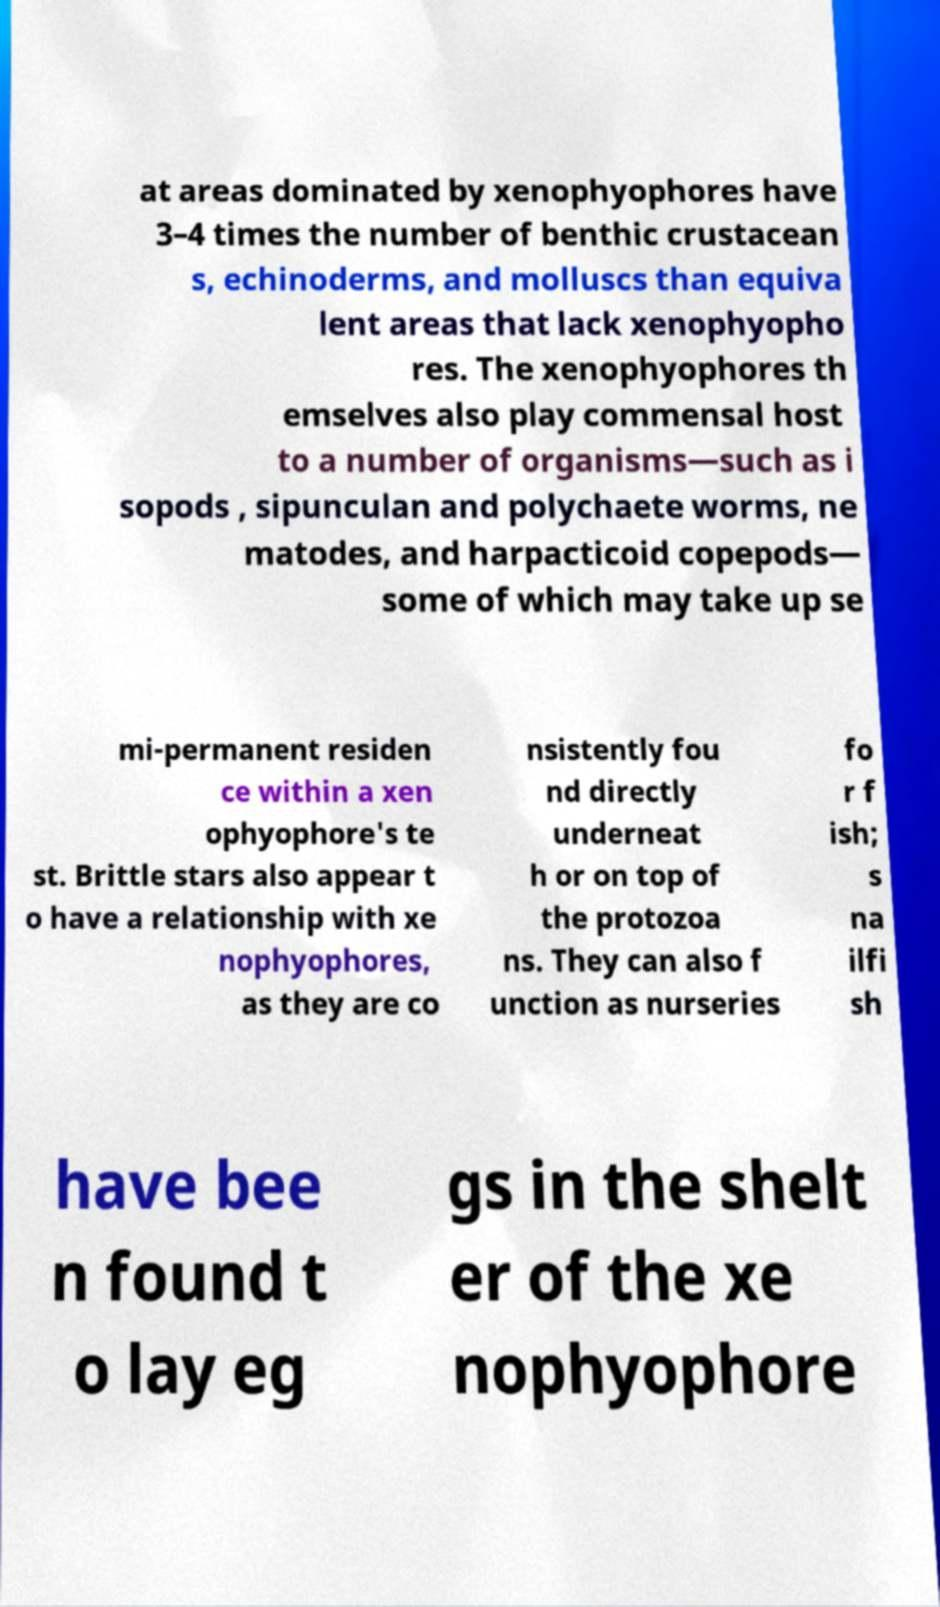I need the written content from this picture converted into text. Can you do that? at areas dominated by xenophyophores have 3–4 times the number of benthic crustacean s, echinoderms, and molluscs than equiva lent areas that lack xenophyopho res. The xenophyophores th emselves also play commensal host to a number of organisms—such as i sopods , sipunculan and polychaete worms, ne matodes, and harpacticoid copepods— some of which may take up se mi-permanent residen ce within a xen ophyophore's te st. Brittle stars also appear t o have a relationship with xe nophyophores, as they are co nsistently fou nd directly underneat h or on top of the protozoa ns. They can also f unction as nurseries fo r f ish; s na ilfi sh have bee n found t o lay eg gs in the shelt er of the xe nophyophore 